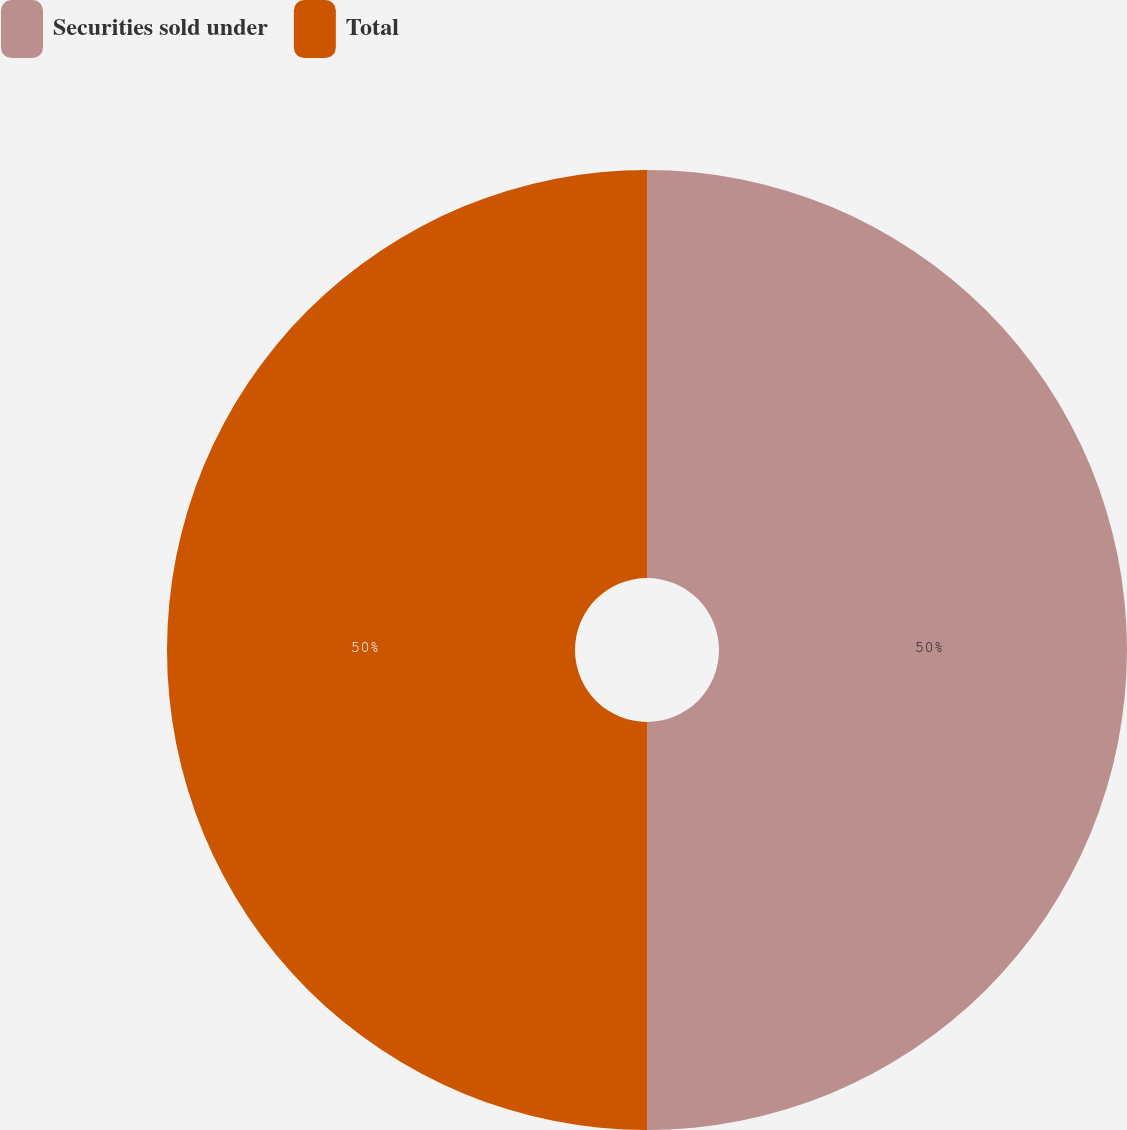Convert chart. <chart><loc_0><loc_0><loc_500><loc_500><pie_chart><fcel>Securities sold under<fcel>Total<nl><fcel>50.0%<fcel>50.0%<nl></chart> 